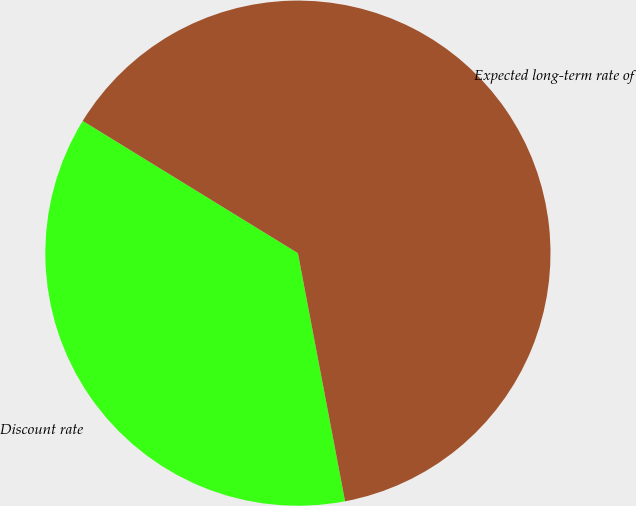Convert chart. <chart><loc_0><loc_0><loc_500><loc_500><pie_chart><fcel>Discount rate<fcel>Expected long-term rate of<nl><fcel>36.76%<fcel>63.24%<nl></chart> 